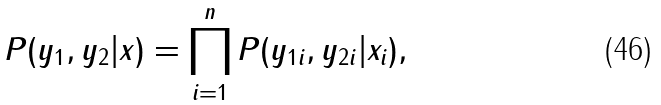<formula> <loc_0><loc_0><loc_500><loc_500>P ( y _ { 1 } , y _ { 2 } | x ) = \prod _ { i = 1 } ^ { n } P ( y _ { 1 i } , y _ { 2 i } | x _ { i } ) ,</formula> 